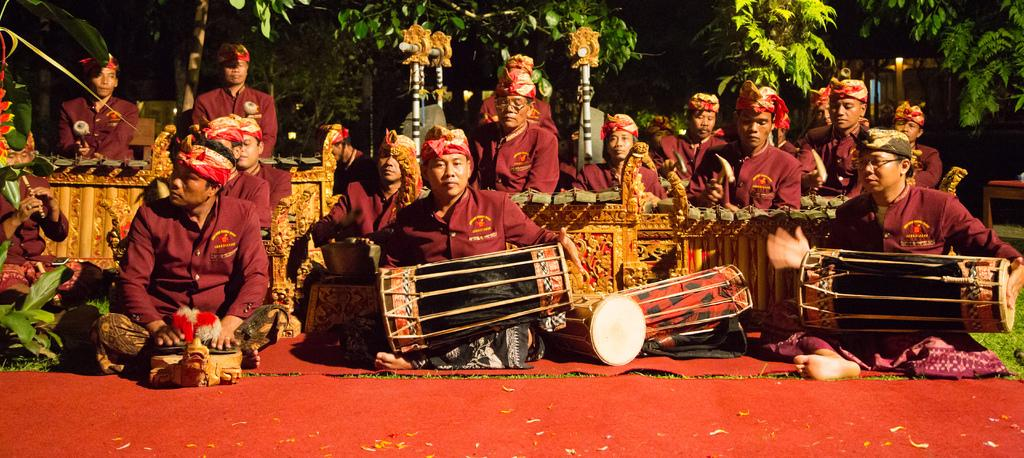What is the main subject of the image? The main subject of the image is a band of musicians. What are the musicians wearing? The musicians are wearing red uniforms. What are the musicians doing in the image? The musicians are playing different types of instruments. What type of cheese is being used to paint the person in the image? There is no cheese or person present in the image; it features a band of musicians playing different types of instruments. 